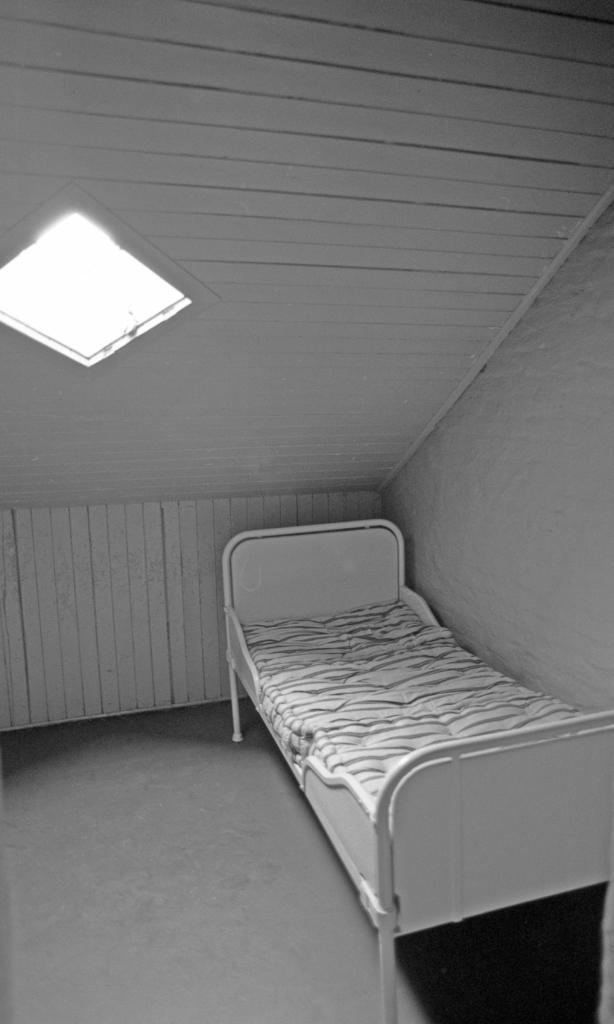Please provide a concise description of this image. It is a black and white image, there is a bed and beside the bed there is a wall and above the bed there is a roof. 